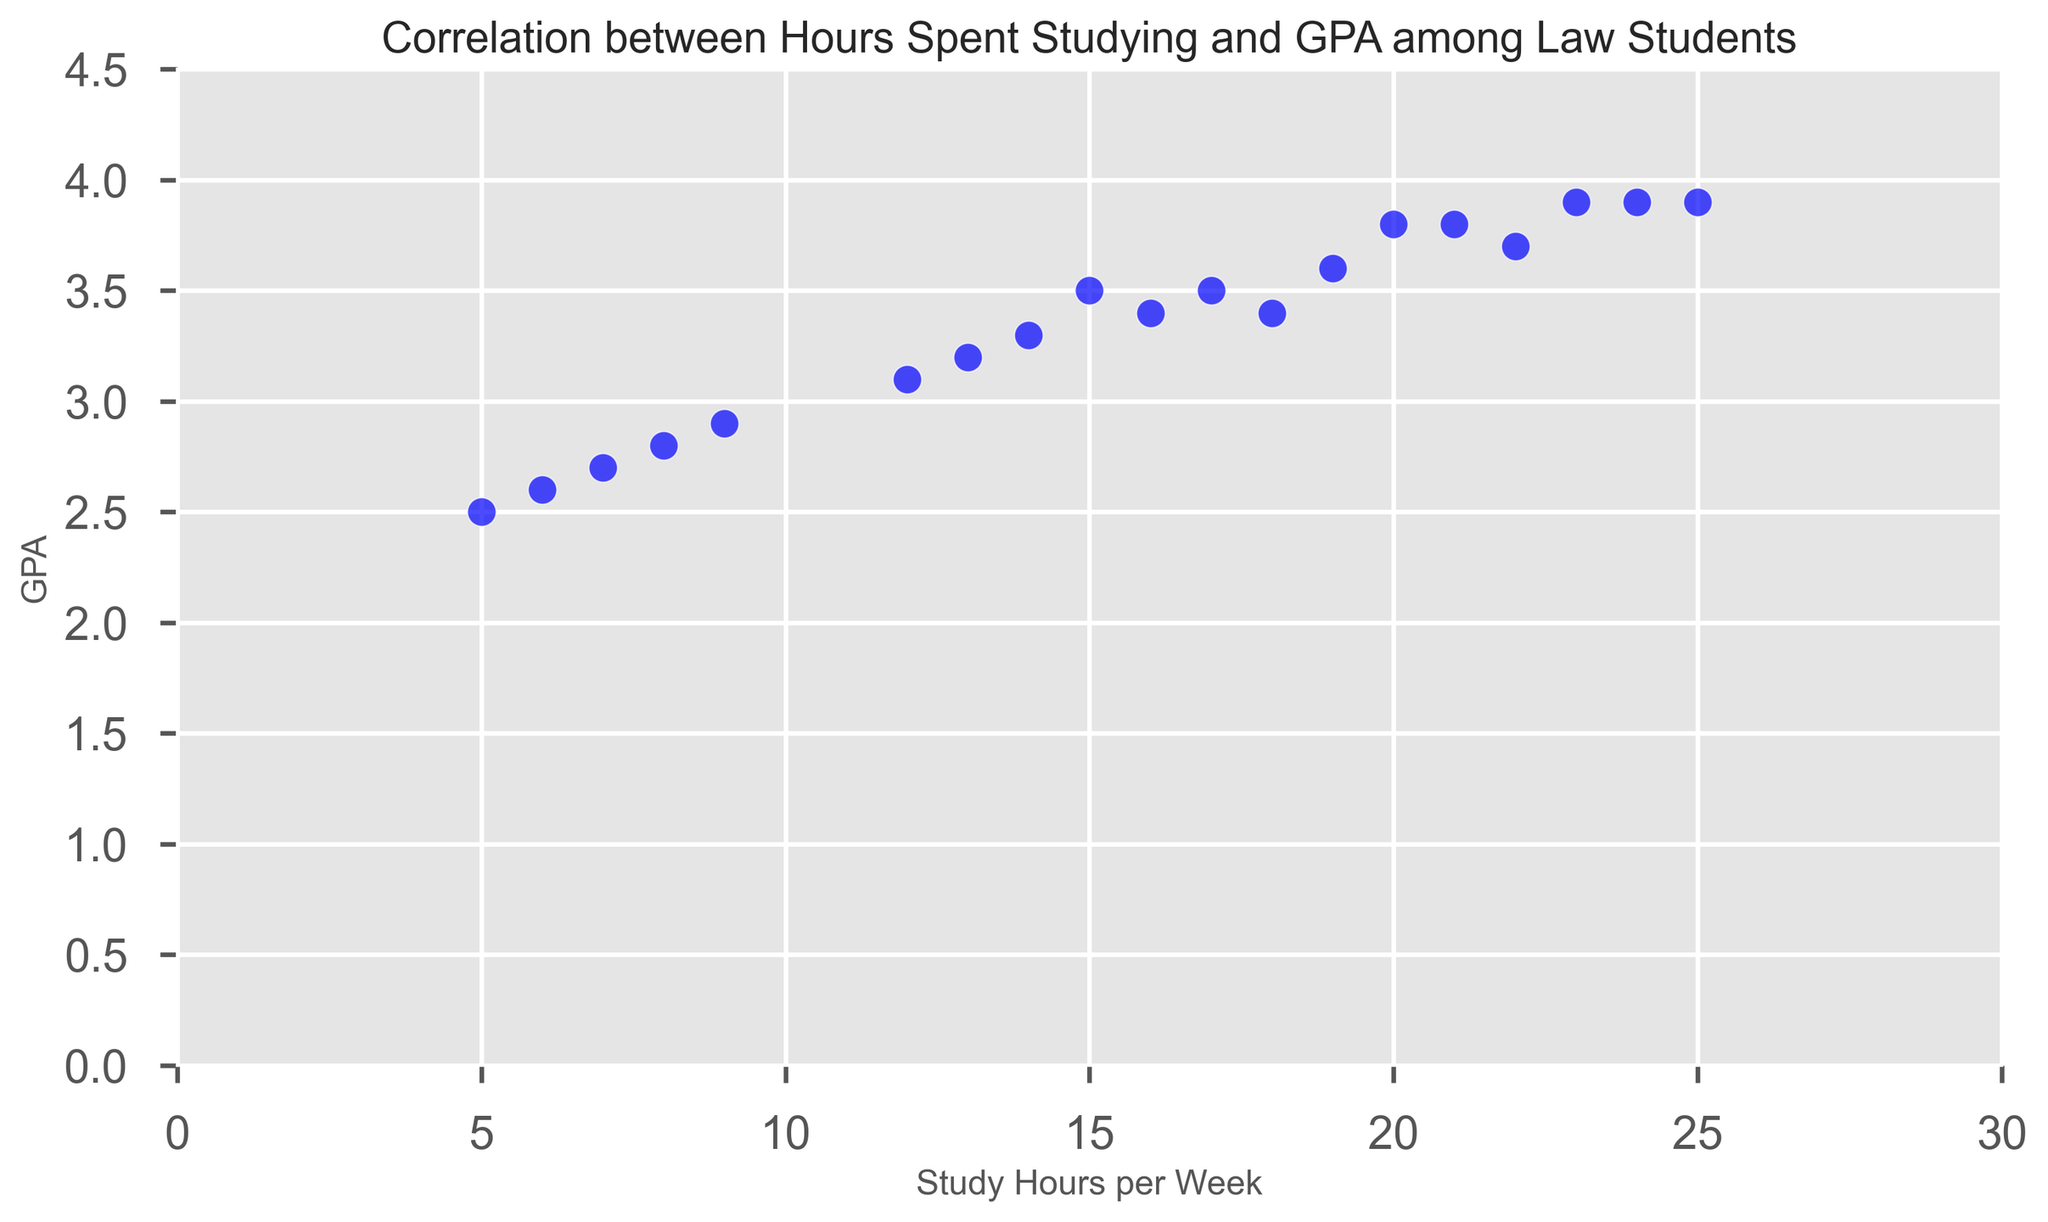What is the correlation between hours spent studying and GPA for law students according to the scatter plot? By observing the trend in the scatter plot, we can identify if there is a pattern between the two variables. Here, it appears that as study hours increase, GPA also tends to increase, suggesting a positive correlation between hours spent studying and GPA.
Answer: Positive Correlation What is the GPA of the student from University of South Carolina who studies 20 hours per week? Locate the data point on the scatter plot corresponding to the University of South Carolina with 20 study hours. The GPA value for this point is 3.8.
Answer: 3.8 Which university has the lowest GPA, and how many hours does the student from that university study? Find the data point with the lowest GPA on the scatter plot and note the corresponding study hours and university. The lowest GPA is 2.5 from Boston University, with the student studying 5 hours per week.
Answer: Boston University, 5 hours How does the GPA of students at Ivy League universities (Harvard, Yale, Columbia, Cornell) compare to other universities? Isolate the data points for Harvard, Yale, Columbia, and Cornell and compare their GPAs with other universities. The GPAs of Ivy League universities generally appear higher, ranging from 3.1 to 3.9, while non-Ivy League universities have a wider range of GPAs including lower values.
Answer: Generally higher What is the range of study hours observed in the scatter plot? Identify the minimum and maximum study hours from the scatter plot. The minimum study hours are 5, and the maximum study hours are 25. Hence, the range is 25 - 5 = 20 hours.
Answer: 20 hours How many students have a GPA of 3.9, and which universities do they attend? Count the number of data points with a GPA of 3.9 and identify the corresponding universities. There are three students with a GPA of 3.9, and they attend Yale University, Northwestern University, and the University of Southern California.
Answer: Three students: Yale University, Northwestern University, University of Southern California Compare the GPA of students who study 15 hours per week with those who study 10 hours per week. Find the data points for students who study 15 and 10 hours per week and compare their GPAs. The GPA for 15 study hours is 3.5 (University of South Carolina), while for 10 study hours, none appear, so we infer the nearest similar data point, which is 9 hours with a GPA of 2.9.
Answer: 3.5 vs. 2.9 What is the average GPA of all students represented in the scatter plot? Sum all the GPA values and divide by the number of data points. GPA values sum to 57.0, and there are 18 data points. Therefore, the average GPA is 57.0 / 18 ≈ 3.17.
Answer: Approximately 3.17 For students who study 20 hours or more per week, what is the average GPA? Identify the data points where study hours are 20 or more, sum the GPAs for these points, and divide by the number of relevant data points. Study hours ≥ 20 include GPAs 3.8, 3.9, 3.7, 3.9, and 3.9, summing to 19.2 over 5 data points. Average GPA: 19.2 / 5 = 3.84.
Answer: 3.84 Which university has the highest variance in study hours among its students? Determine if there are multiple data points per university and calculate the variance for those universities. Since only single data points per university are given, an accurate variance cannot be determined from this scatter plot visually. Therefore, this question is non-applicable with the given data set.
Answer: Non-applicable 